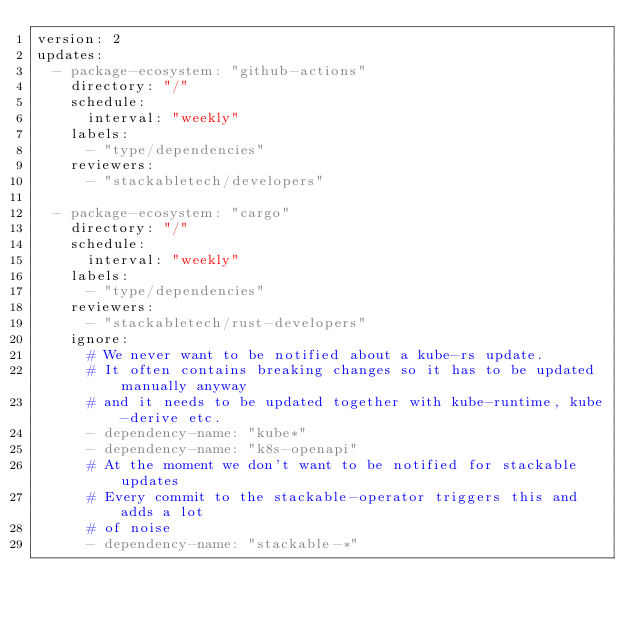<code> <loc_0><loc_0><loc_500><loc_500><_YAML_>version: 2
updates:
  - package-ecosystem: "github-actions"
    directory: "/"
    schedule:
      interval: "weekly"
    labels:
      - "type/dependencies"
    reviewers:
      - "stackabletech/developers"

  - package-ecosystem: "cargo"
    directory: "/"
    schedule:
      interval: "weekly"
    labels:
      - "type/dependencies"
    reviewers:
      - "stackabletech/rust-developers"
    ignore:
      # We never want to be notified about a kube-rs update.
      # It often contains breaking changes so it has to be updated manually anyway
      # and it needs to be updated together with kube-runtime, kube-derive etc.
      - dependency-name: "kube*"
      - dependency-name: "k8s-openapi"
      # At the moment we don't want to be notified for stackable updates
      # Every commit to the stackable-operator triggers this and adds a lot
      # of noise
      - dependency-name: "stackable-*"
</code> 